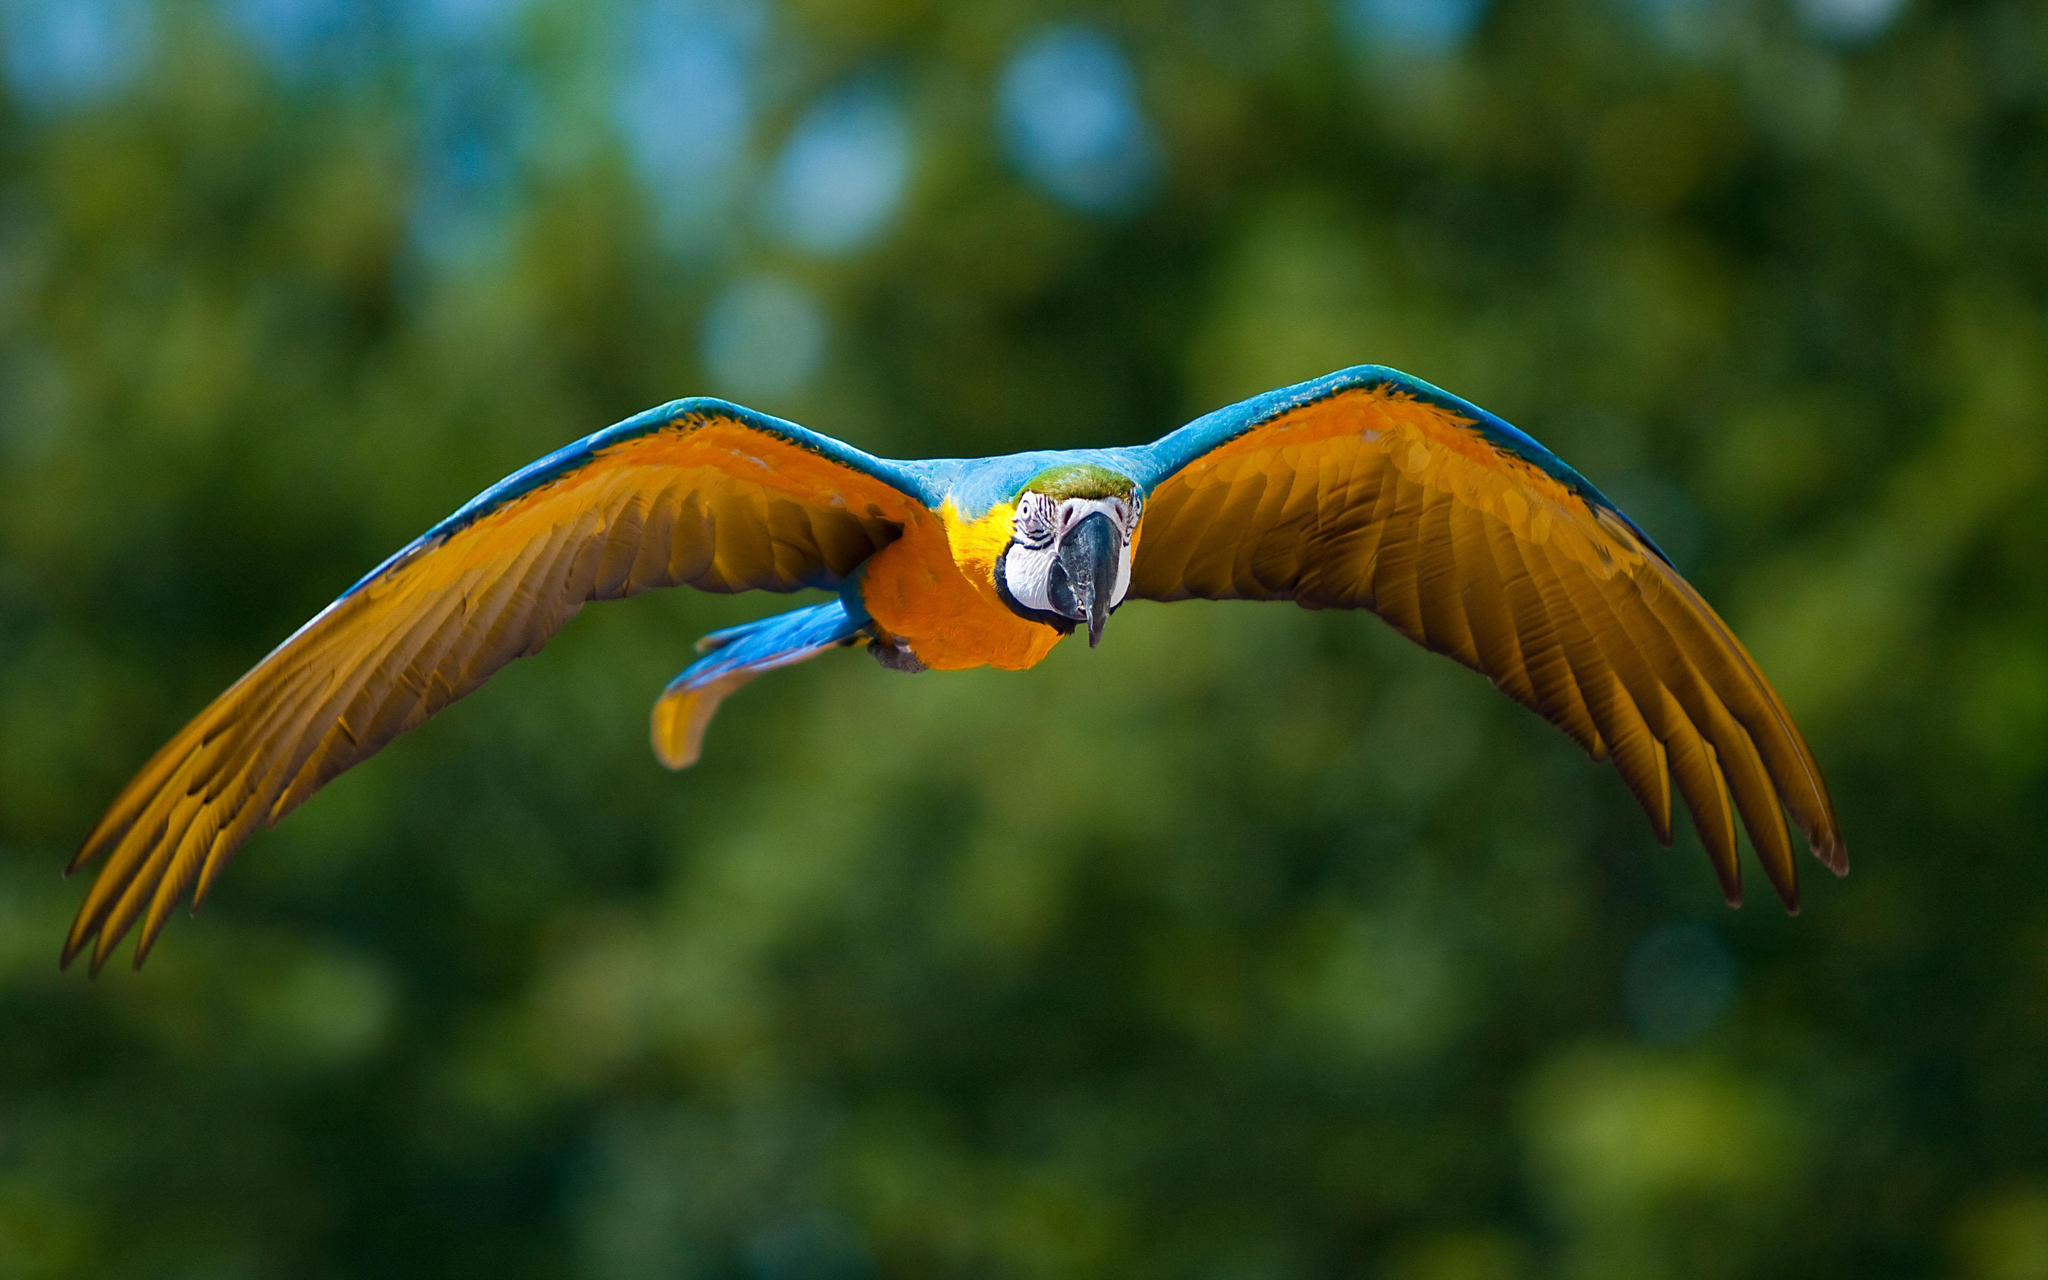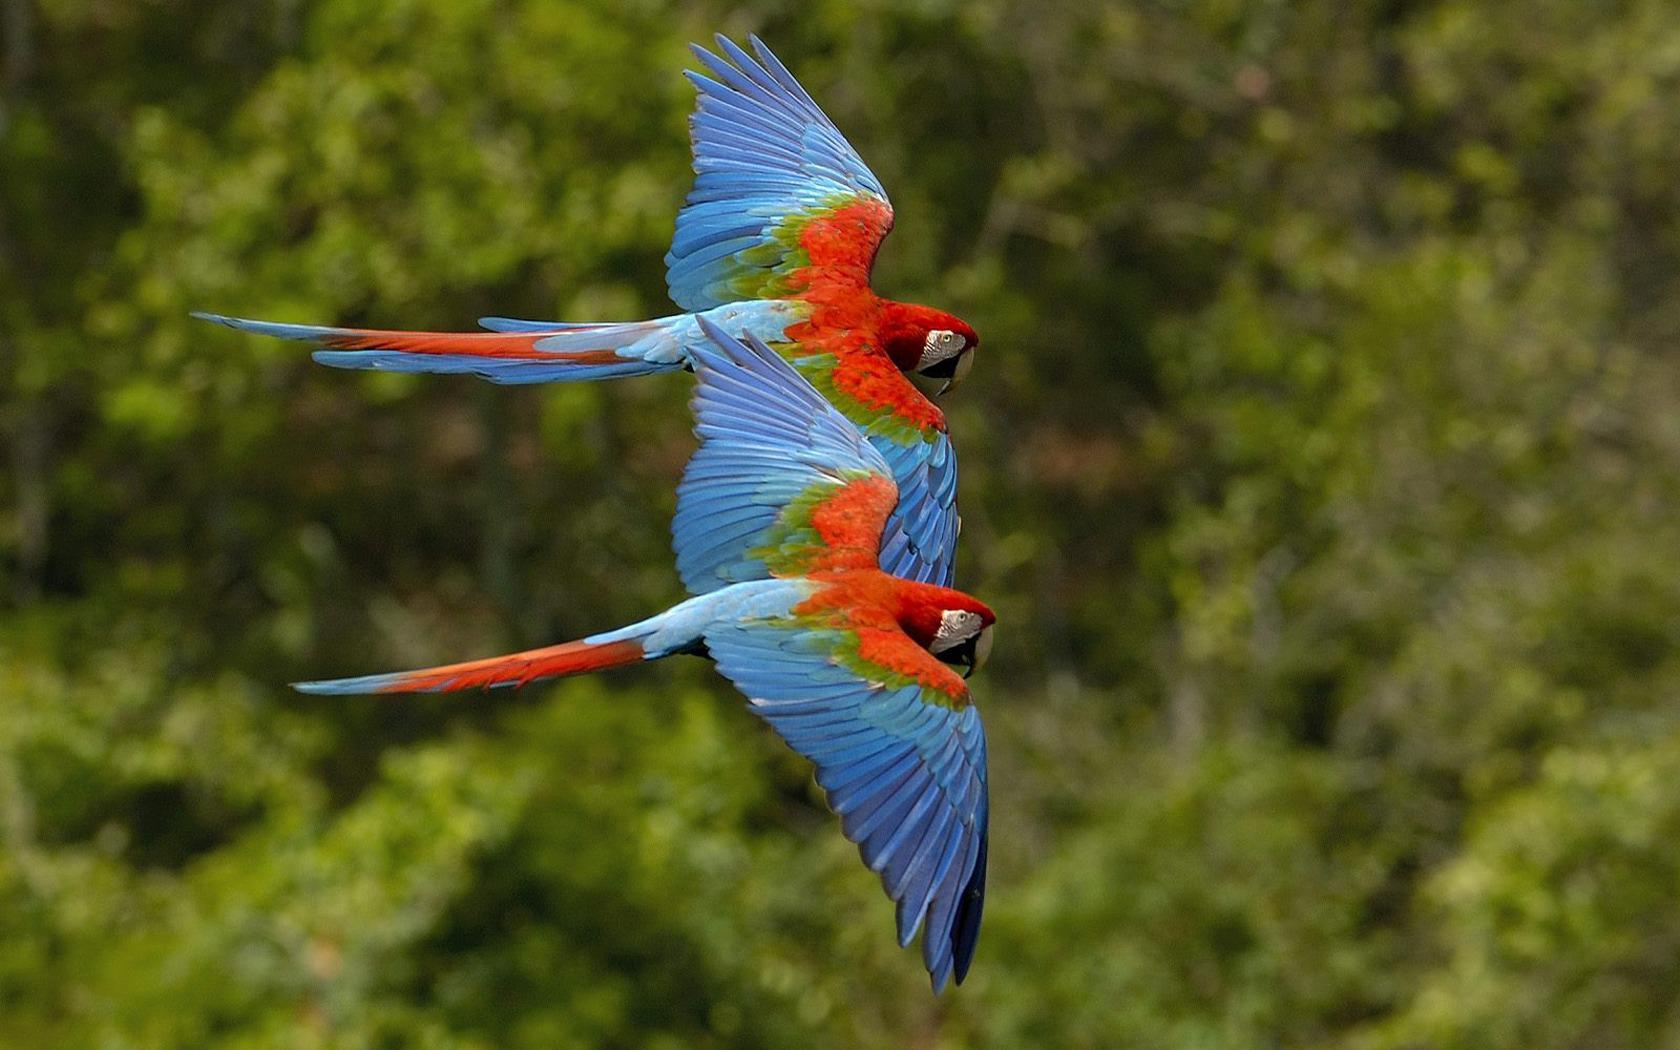The first image is the image on the left, the second image is the image on the right. Evaluate the accuracy of this statement regarding the images: "The bird in one of the images is flying to the left.". Is it true? Answer yes or no. No. 